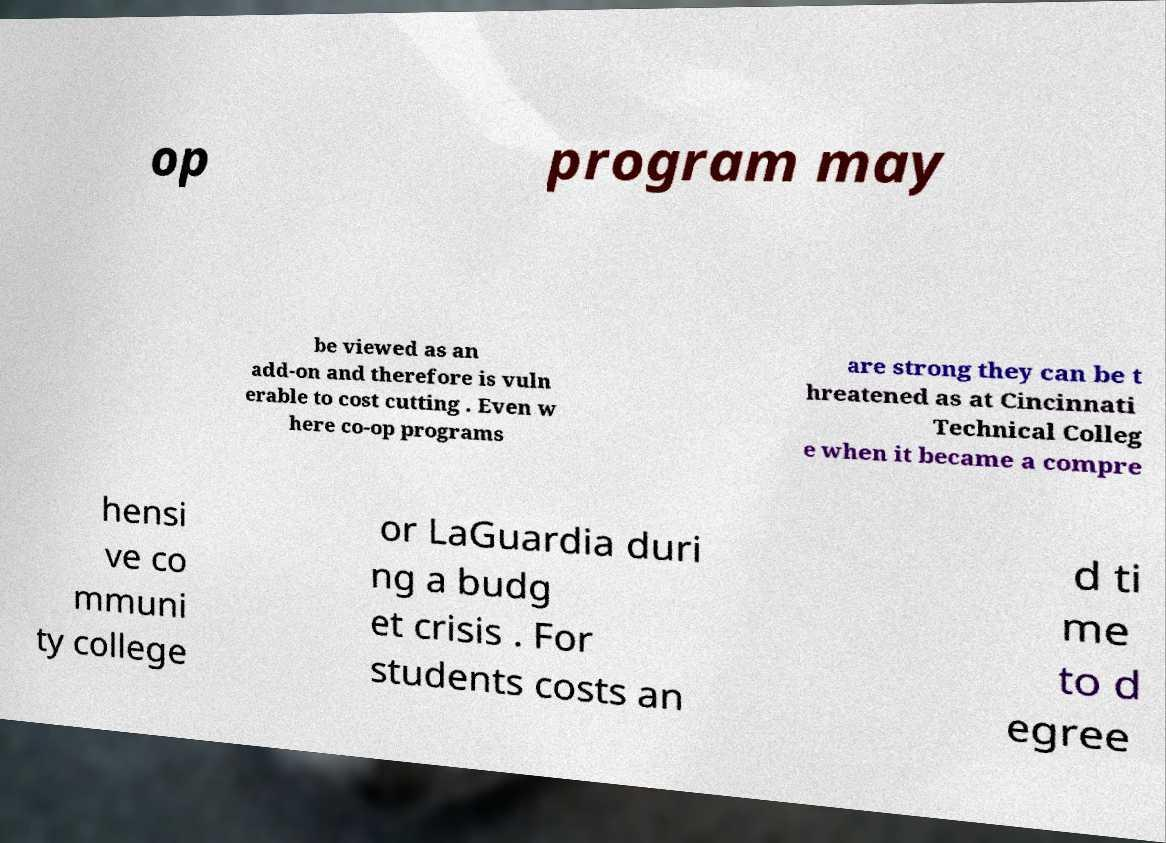What messages or text are displayed in this image? I need them in a readable, typed format. op program may be viewed as an add-on and therefore is vuln erable to cost cutting . Even w here co-op programs are strong they can be t hreatened as at Cincinnati Technical Colleg e when it became a compre hensi ve co mmuni ty college or LaGuardia duri ng a budg et crisis . For students costs an d ti me to d egree 